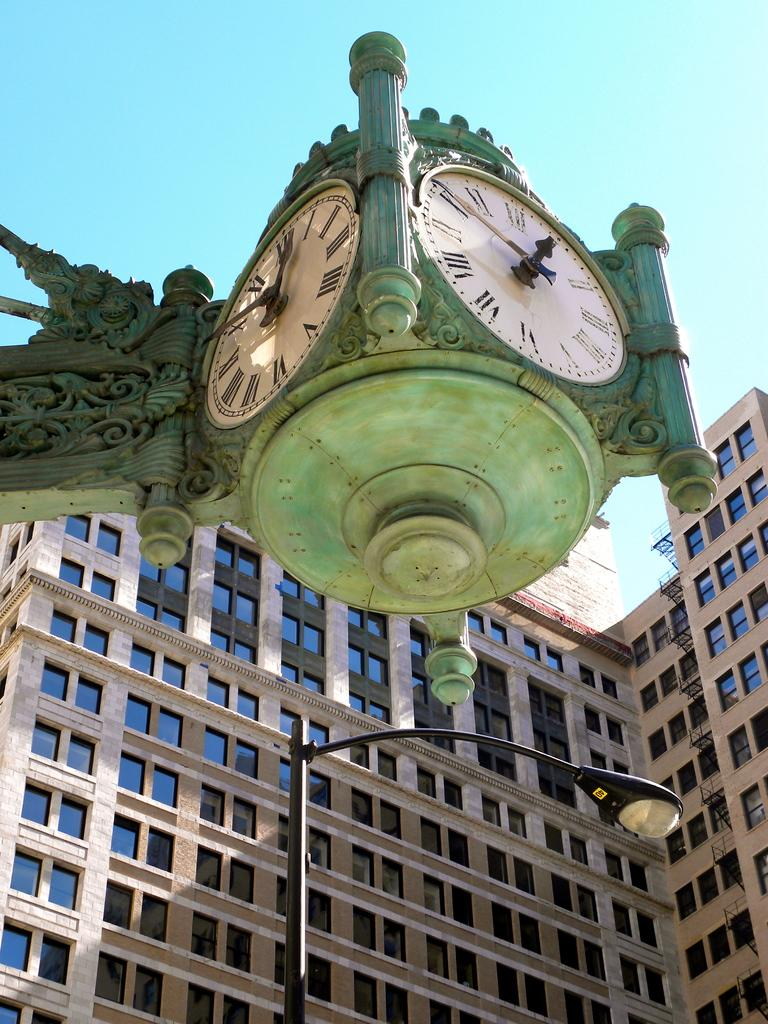<image>
Give a short and clear explanation of the subsequent image. An antiqued clock near a building reads 12:50. 